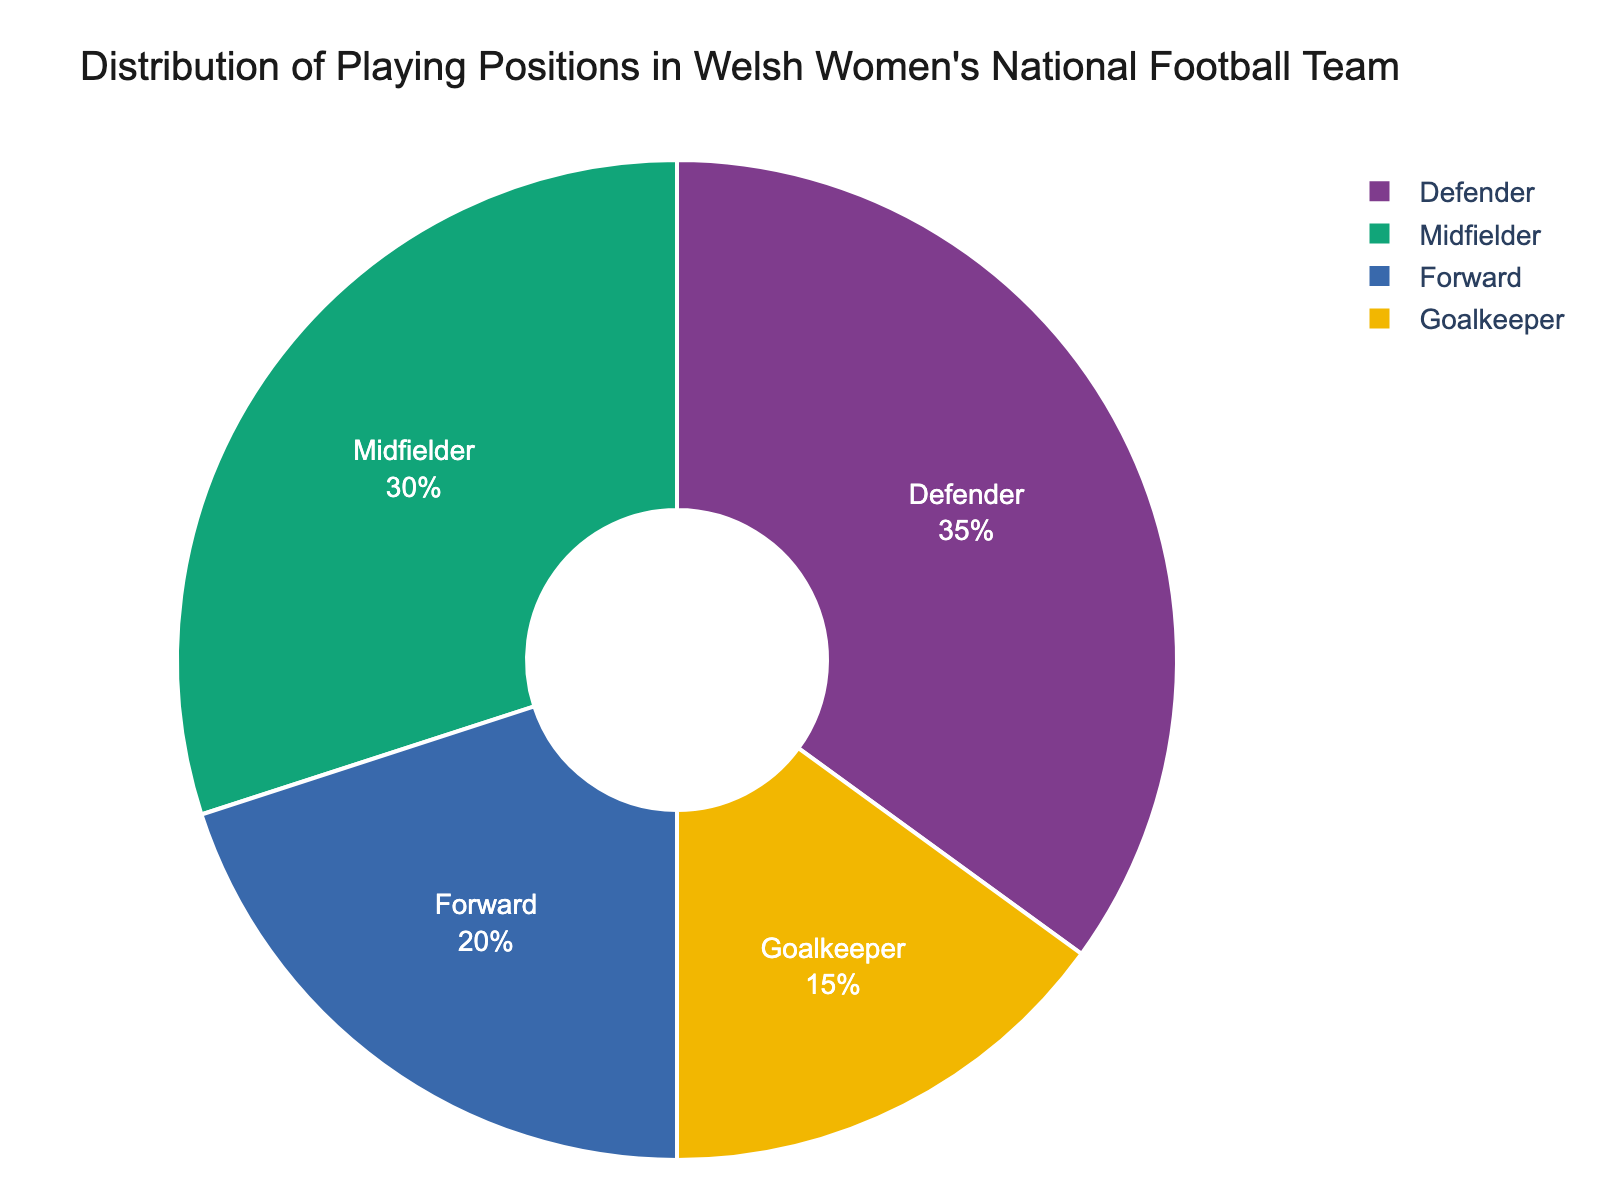What is the most common playing position in the Welsh women's national football team? The pie chart shows the distribution of playing positions, and the position with the largest percentage slice is the most common. Here, it is the Defender position with 35%.
Answer: Defender What percentage of the team are Goalkeepers? The pie chart includes a slice labeled "Goalkeeper" with the percentage indicated. It shows 15%.
Answer: 15% Is the percentage of Midfielders higher than the percentage of Forwards? The pie chart indicates that Midfielders make up 30% while Forwards make up 20%. Since 30% is greater than 20%, the percentage of Midfielders is indeed higher.
Answer: Yes What is the total percentage of Forwards and Goalkeepers combined? Add the percentages of Forwards (20%) and Goalkeepers (15%). The total is 20% + 15% = 35%.
Answer: 35% Which position has the smallest representation in the team? The smallest slice in the pie chart is for the Goalkeeper position, which is 15%.
Answer: Goalkeeper What is the difference in percentage between Defenders and Forwards? Subtract the percentage of Forwards (20%) from the percentage of Defenders (35%). The difference is 35% - 20% = 15%.
Answer: 15% Is the combined percentage of Midfielders and Defenders more than half of the team's composition? Add the percentages of Midfielders (30%) and Defenders (35%). Their combined percentage is 30% + 35% = 65%, which is more than 50%.
Answer: Yes How does the distribution of Midfielders and Forwards compare visually? Visually, the Midfielders' slice is larger than the Forwards' slice. Midfielders have a 30% representation whereas Forwards have a 20% representation.
Answer: Midfielders have a larger slice What is the average percentage of all playing positions? Add all the percentages together (20% + 30% + 35% + 15% = 100%) and divide by the number of positions (4). The average is 100% / 4 = 25%.
Answer: 25% If a new player is added to the team as a Forward, how would this affect the distribution? Currently, Forwards are 20% of the team. Adding one player would change the proportion, decreasing the percentages of other positions. The exact new distribution would depend on the total number of players, which is not provided.
Answer: Proportion increases for Forwards, others decrease, exact change unknown 